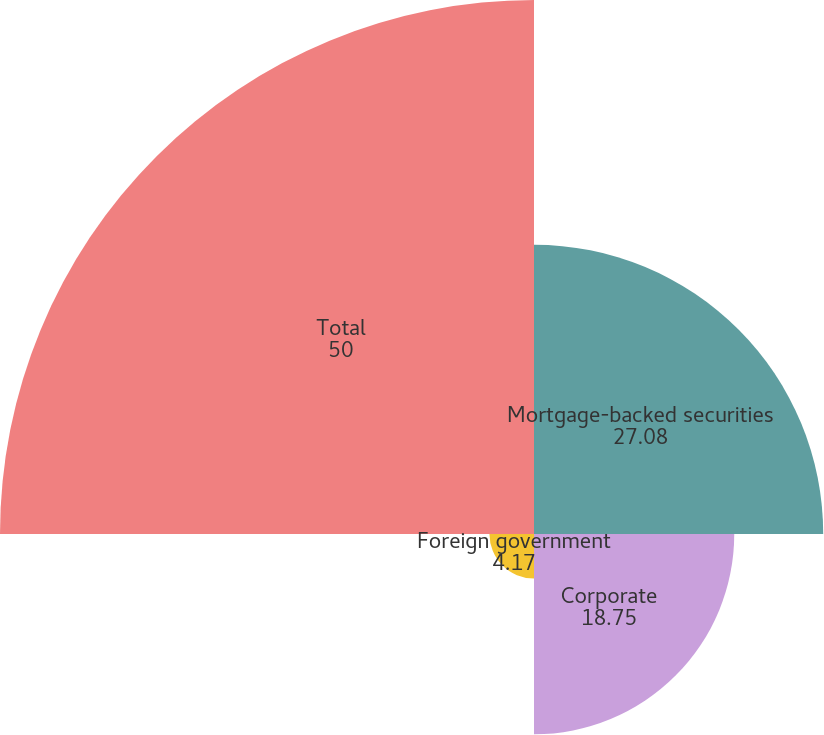<chart> <loc_0><loc_0><loc_500><loc_500><pie_chart><fcel>Mortgage-backed securities<fcel>Corporate<fcel>Foreign government<fcel>Total<nl><fcel>27.08%<fcel>18.75%<fcel>4.17%<fcel>50.0%<nl></chart> 